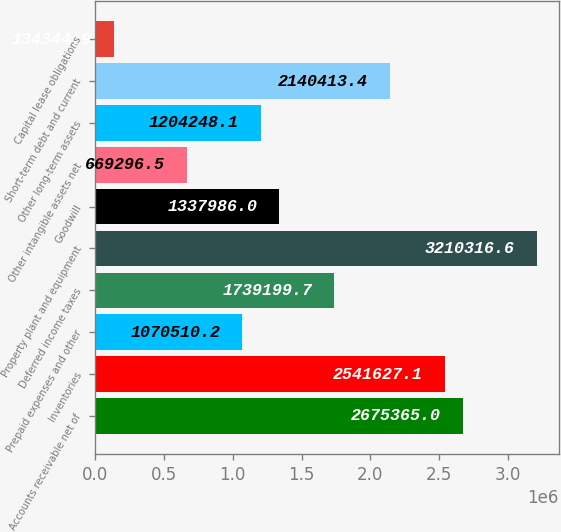Convert chart to OTSL. <chart><loc_0><loc_0><loc_500><loc_500><bar_chart><fcel>Accounts receivable net of<fcel>Inventories<fcel>Prepaid expenses and other<fcel>Deferred income taxes<fcel>Property plant and equipment<fcel>Goodwill<fcel>Other intangible assets net<fcel>Other long-term assets<fcel>Short-term debt and current<fcel>Capital lease obligations<nl><fcel>2.67536e+06<fcel>2.54163e+06<fcel>1.07051e+06<fcel>1.7392e+06<fcel>3.21032e+06<fcel>1.33799e+06<fcel>669296<fcel>1.20425e+06<fcel>2.14041e+06<fcel>134345<nl></chart> 